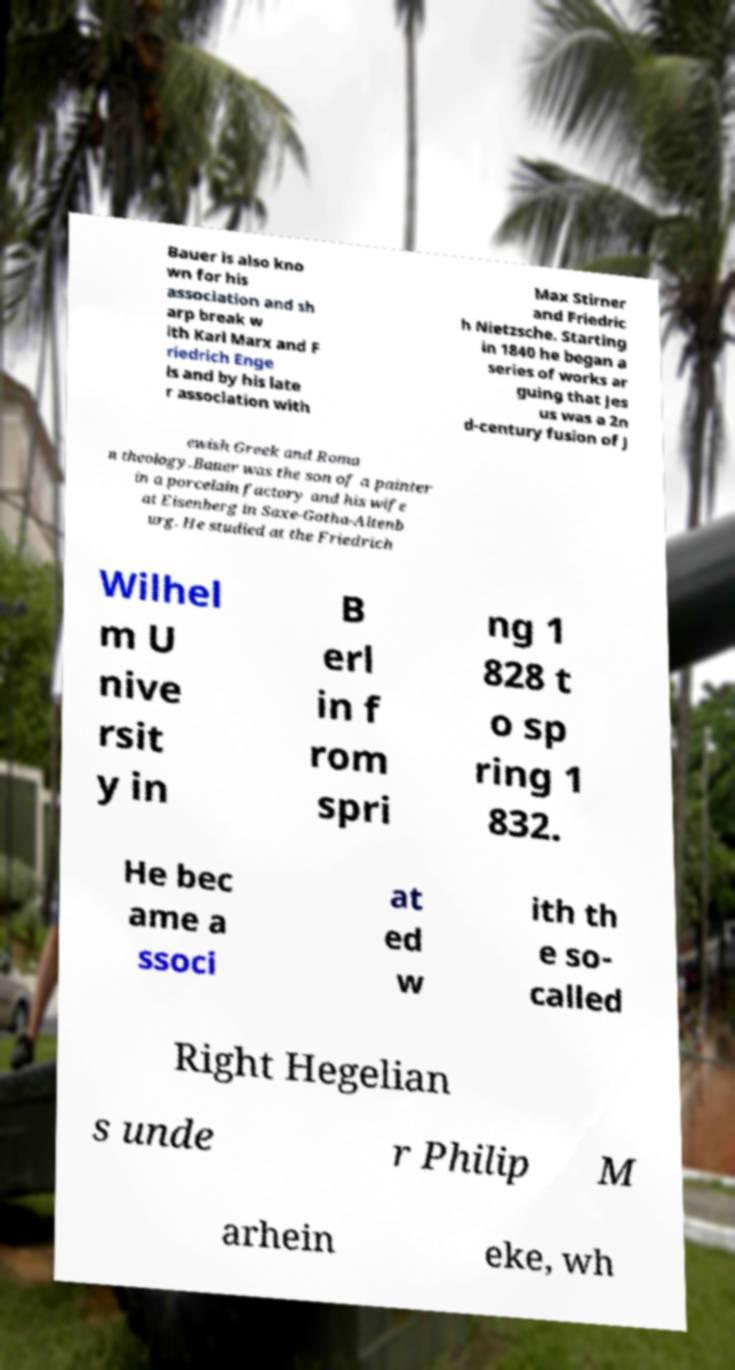Could you extract and type out the text from this image? Bauer is also kno wn for his association and sh arp break w ith Karl Marx and F riedrich Enge ls and by his late r association with Max Stirner and Friedric h Nietzsche. Starting in 1840 he began a series of works ar guing that Jes us was a 2n d-century fusion of J ewish Greek and Roma n theology.Bauer was the son of a painter in a porcelain factory and his wife at Eisenberg in Saxe-Gotha-Altenb urg. He studied at the Friedrich Wilhel m U nive rsit y in B erl in f rom spri ng 1 828 t o sp ring 1 832. He bec ame a ssoci at ed w ith th e so- called Right Hegelian s unde r Philip M arhein eke, wh 